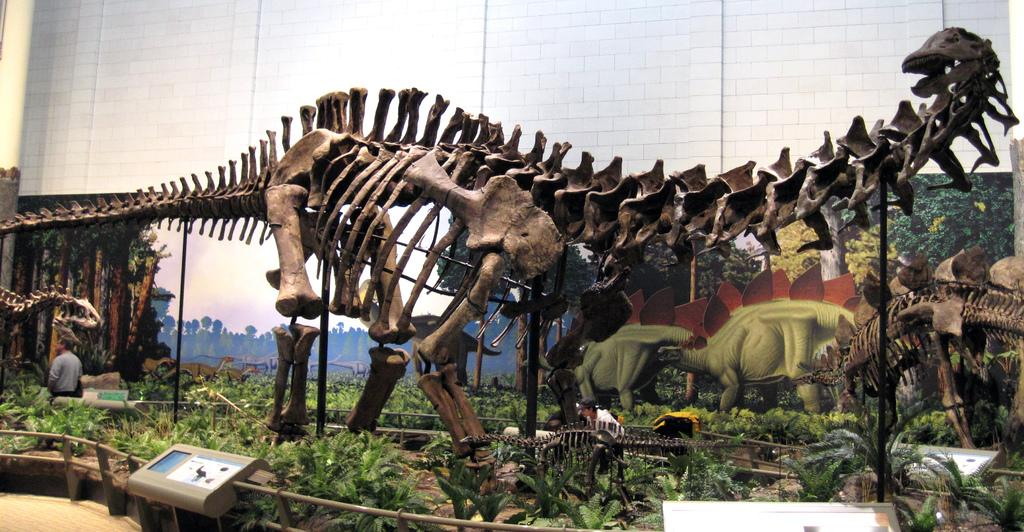What type of remains can be seen in the image? There are skeletons of animals in the image. What structures are present in the image? There are poles and fencing in the image. What type of vegetation is visible in the image? There are plants in the image. What objects are related to technology in the image? Electronic gadgets are visible in the image. How many people are in the image? There are two persons in the image. What type of artwork is present on the wall in the image? There are paintings on the wall in the image. What type of worm can be seen crawling on the straw in the image? There is no worm or straw present in the image. What type of game is being played by the two persons in the image? There is no game being played by the two persons in the image; they are not engaged in any activity. 